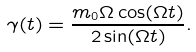<formula> <loc_0><loc_0><loc_500><loc_500>\gamma ( t ) = \frac { m _ { 0 } \Omega \cos ( \Omega t ) } { 2 \sin ( \Omega t ) } .</formula> 